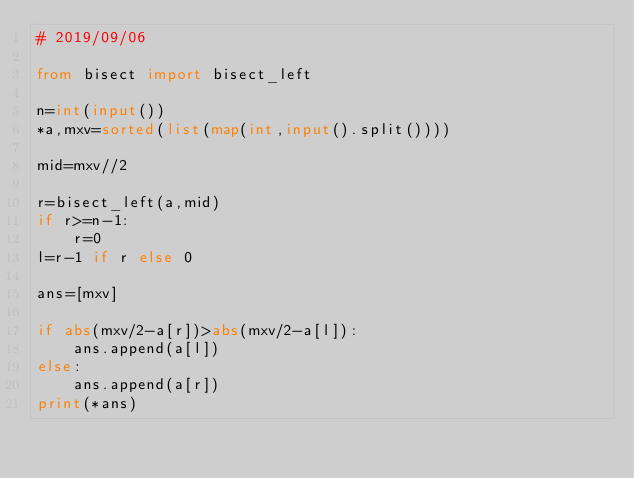<code> <loc_0><loc_0><loc_500><loc_500><_Python_># 2019/09/06

from bisect import bisect_left

n=int(input())
*a,mxv=sorted(list(map(int,input().split())))

mid=mxv//2

r=bisect_left(a,mid) 
if r>=n-1:
    r=0
l=r-1 if r else 0

ans=[mxv]

if abs(mxv/2-a[r])>abs(mxv/2-a[l]):
    ans.append(a[l])
else:
    ans.append(a[r])
print(*ans)</code> 